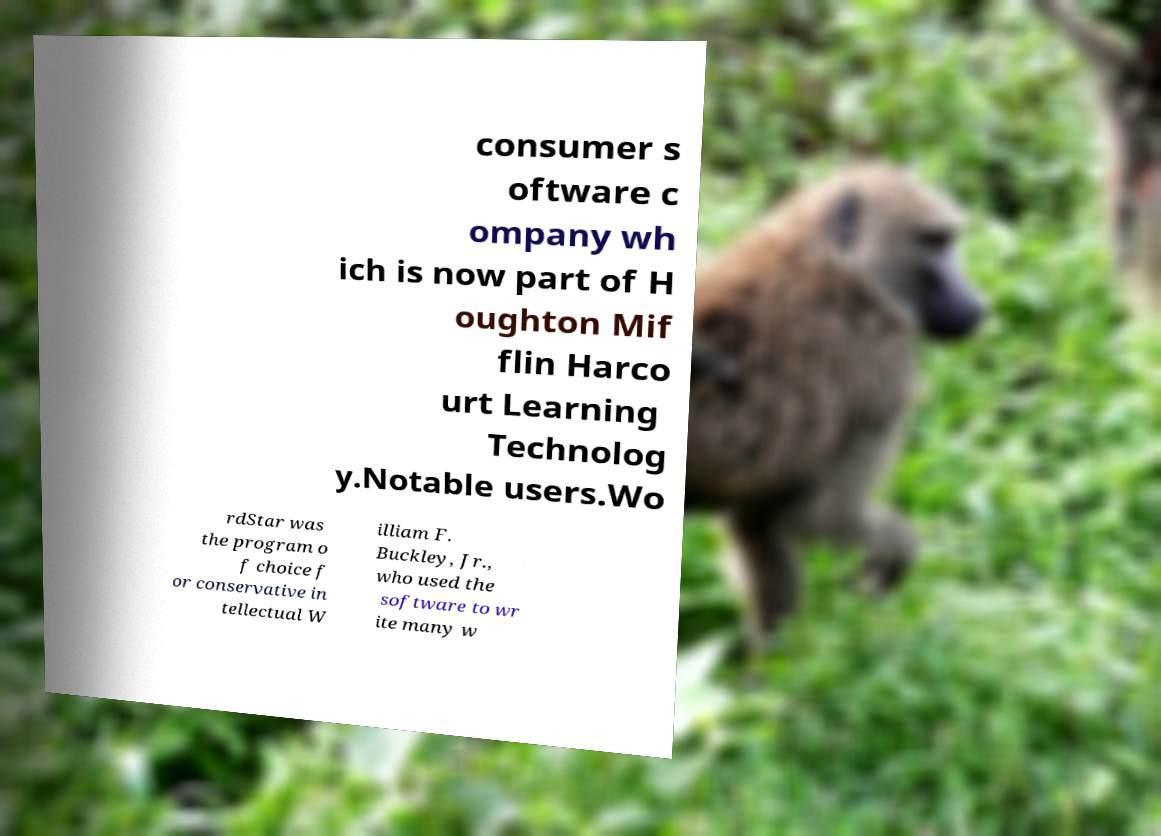Please identify and transcribe the text found in this image. consumer s oftware c ompany wh ich is now part of H oughton Mif flin Harco urt Learning Technolog y.Notable users.Wo rdStar was the program o f choice f or conservative in tellectual W illiam F. Buckley, Jr., who used the software to wr ite many w 